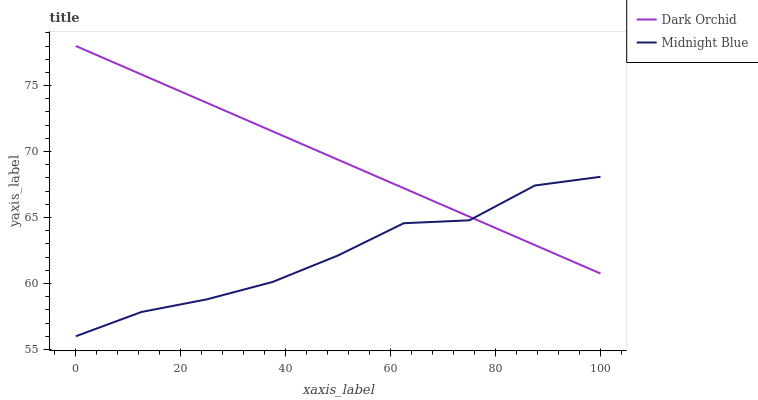Does Midnight Blue have the minimum area under the curve?
Answer yes or no. Yes. Does Dark Orchid have the maximum area under the curve?
Answer yes or no. Yes. Does Dark Orchid have the minimum area under the curve?
Answer yes or no. No. Is Dark Orchid the smoothest?
Answer yes or no. Yes. Is Midnight Blue the roughest?
Answer yes or no. Yes. Is Dark Orchid the roughest?
Answer yes or no. No. Does Dark Orchid have the lowest value?
Answer yes or no. No. 